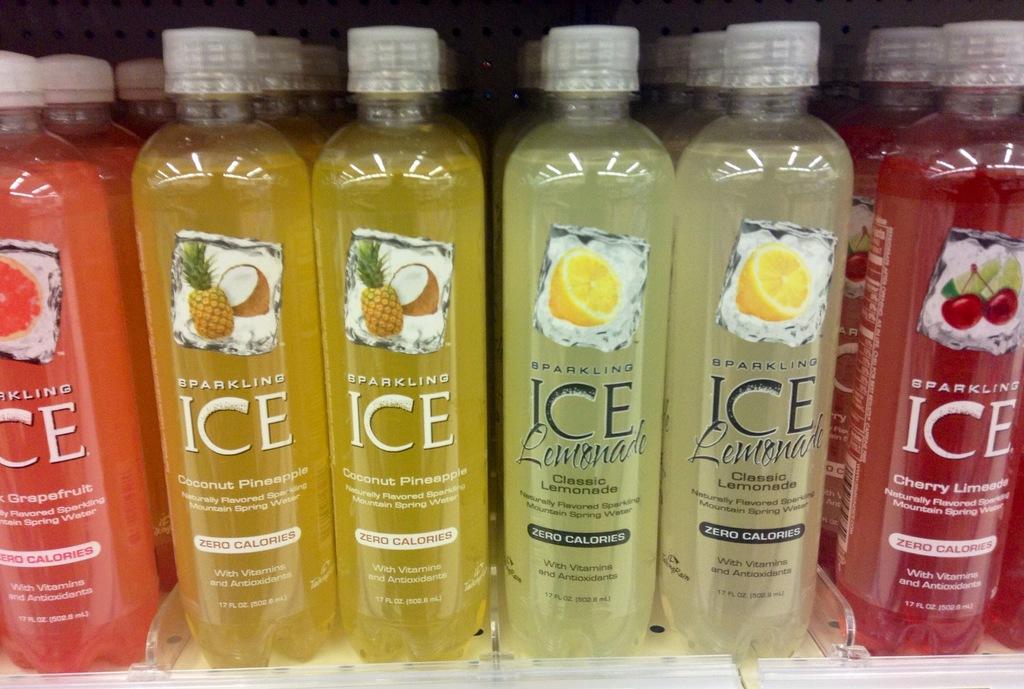What kind of drink is this?
Offer a terse response. Sparkling ice. What kind of calories is in this drink?
Provide a short and direct response. Zero. 